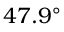Convert formula to latex. <formula><loc_0><loc_0><loc_500><loc_500>4 7 . 9 ^ { \circ }</formula> 